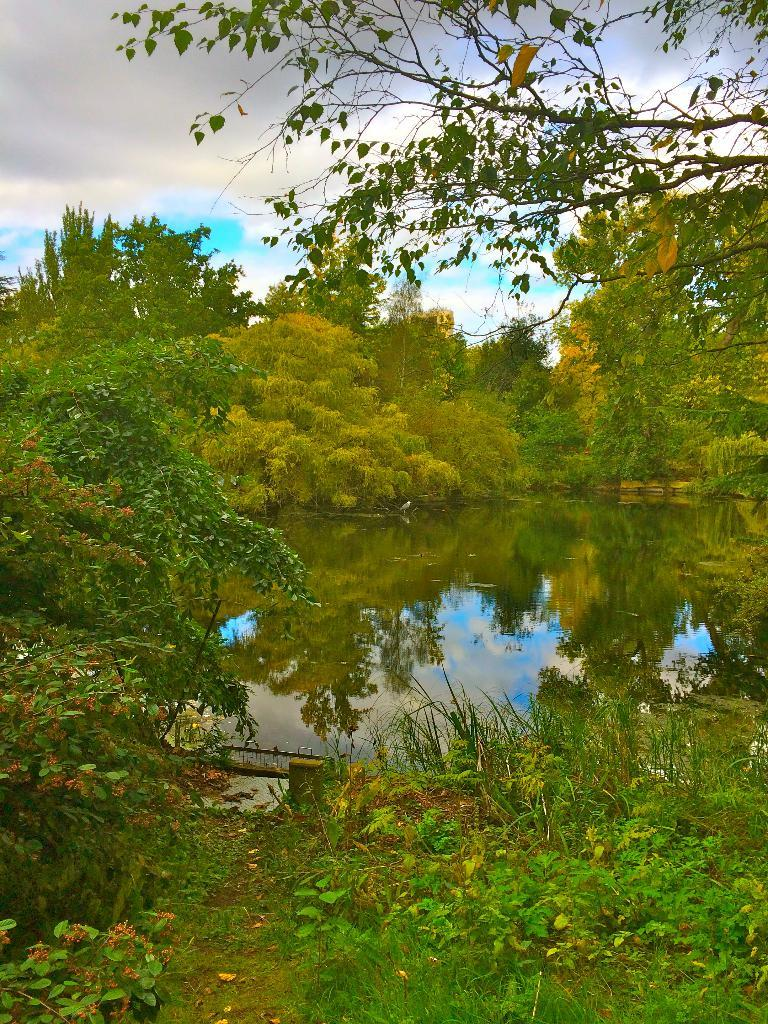What type of vegetation can be seen in the image? There are plants and trees in the image. What natural element is visible in the image? There is water visible in the image. What can be seen in the sky in the image? There are clouds in the image. Can you see an egg being carried by a person in the image? There is no egg or person present in the image. 